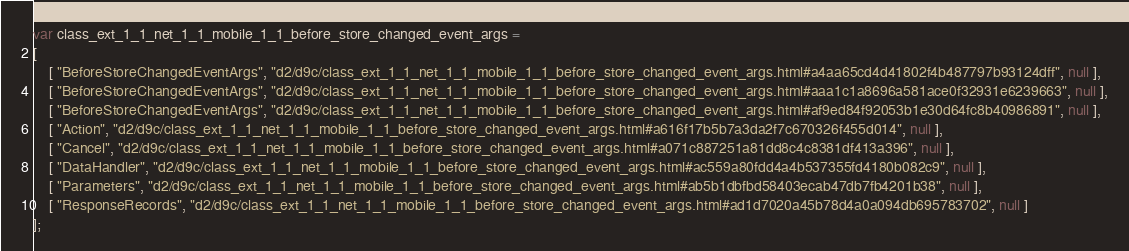<code> <loc_0><loc_0><loc_500><loc_500><_JavaScript_>var class_ext_1_1_net_1_1_mobile_1_1_before_store_changed_event_args =
[
    [ "BeforeStoreChangedEventArgs", "d2/d9c/class_ext_1_1_net_1_1_mobile_1_1_before_store_changed_event_args.html#a4aa65cd4d41802f4b487797b93124dff", null ],
    [ "BeforeStoreChangedEventArgs", "d2/d9c/class_ext_1_1_net_1_1_mobile_1_1_before_store_changed_event_args.html#aaa1c1a8696a581ace0f32931e6239663", null ],
    [ "BeforeStoreChangedEventArgs", "d2/d9c/class_ext_1_1_net_1_1_mobile_1_1_before_store_changed_event_args.html#af9ed84f92053b1e30d64fc8b40986891", null ],
    [ "Action", "d2/d9c/class_ext_1_1_net_1_1_mobile_1_1_before_store_changed_event_args.html#a616f17b5b7a3da2f7c670326f455d014", null ],
    [ "Cancel", "d2/d9c/class_ext_1_1_net_1_1_mobile_1_1_before_store_changed_event_args.html#a071c887251a81dd8c4c8381df413a396", null ],
    [ "DataHandler", "d2/d9c/class_ext_1_1_net_1_1_mobile_1_1_before_store_changed_event_args.html#ac559a80fdd4a4b537355fd4180b082c9", null ],
    [ "Parameters", "d2/d9c/class_ext_1_1_net_1_1_mobile_1_1_before_store_changed_event_args.html#ab5b1dbfbd58403ecab47db7fb4201b38", null ],
    [ "ResponseRecords", "d2/d9c/class_ext_1_1_net_1_1_mobile_1_1_before_store_changed_event_args.html#ad1d7020a45b78d4a0a094db695783702", null ]
];</code> 